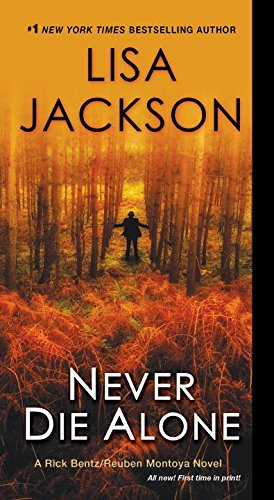Is this book related to Mystery, Thriller & Suspense? Yes, this book is indeed related to the Mystery, Thriller & Suspense genres, featuring complex plots and deep character exploration typical of Lisa Jackson's novels. 